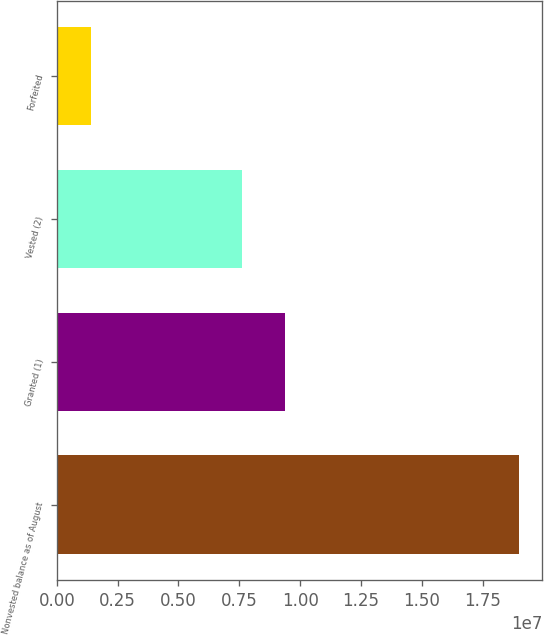Convert chart to OTSL. <chart><loc_0><loc_0><loc_500><loc_500><bar_chart><fcel>Nonvested balance as of August<fcel>Granted (1)<fcel>Vested (2)<fcel>Forfeited<nl><fcel>1.90021e+07<fcel>9.39355e+06<fcel>7.62512e+06<fcel>1.39432e+06<nl></chart> 